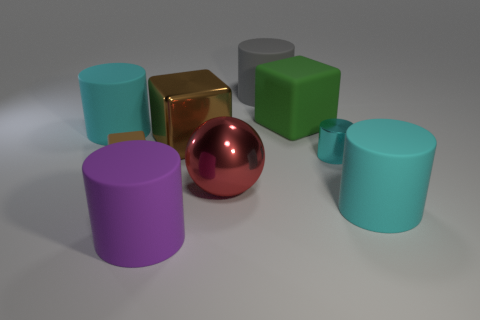Are there an equal number of small rubber things that are right of the large purple rubber thing and tiny green rubber cylinders? Yes, after a close examination, there are an equal number of small rubber things to the right of the large purple rubber thing as there are tiny green rubber cylinders in the image. This balance creates a symmetrical visual dynamic that is quite pleasing to the eye. 